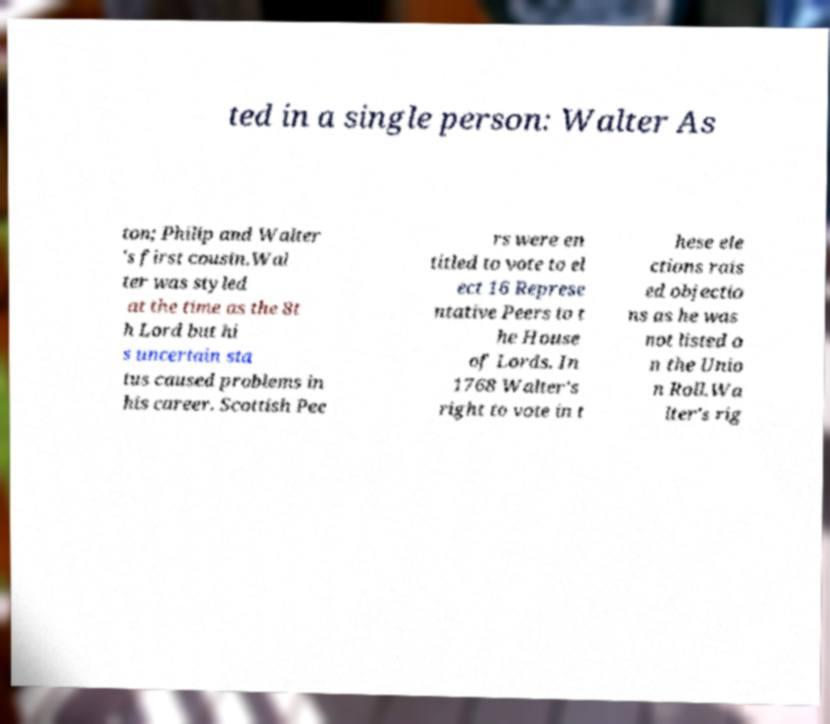For documentation purposes, I need the text within this image transcribed. Could you provide that? ted in a single person: Walter As ton; Philip and Walter 's first cousin.Wal ter was styled at the time as the 8t h Lord but hi s uncertain sta tus caused problems in his career. Scottish Pee rs were en titled to vote to el ect 16 Represe ntative Peers to t he House of Lords. In 1768 Walter's right to vote in t hese ele ctions rais ed objectio ns as he was not listed o n the Unio n Roll.Wa lter's rig 